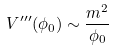Convert formula to latex. <formula><loc_0><loc_0><loc_500><loc_500>V ^ { \prime \prime \prime } ( \phi _ { 0 } ) \sim \frac { m ^ { 2 } } { \phi _ { 0 } }</formula> 